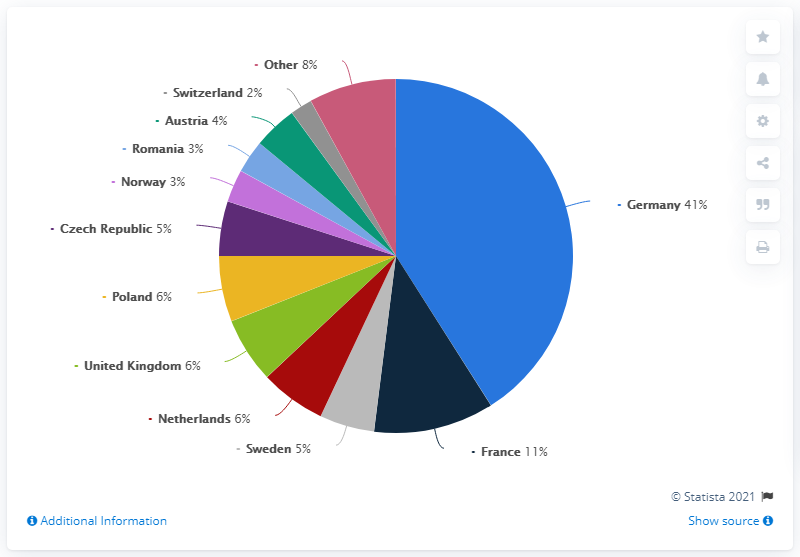Identify some key points in this picture. In 2019, Denmark held a significant 6% percentage share of Christmas tree exports in Poland. In 2019, 41% of Denmark's Christmas trees were exported to Germany. The product of the two smallest segments of the pie chart is 6. In 2019, Denmark exported the most Christmas trees to Germany. 